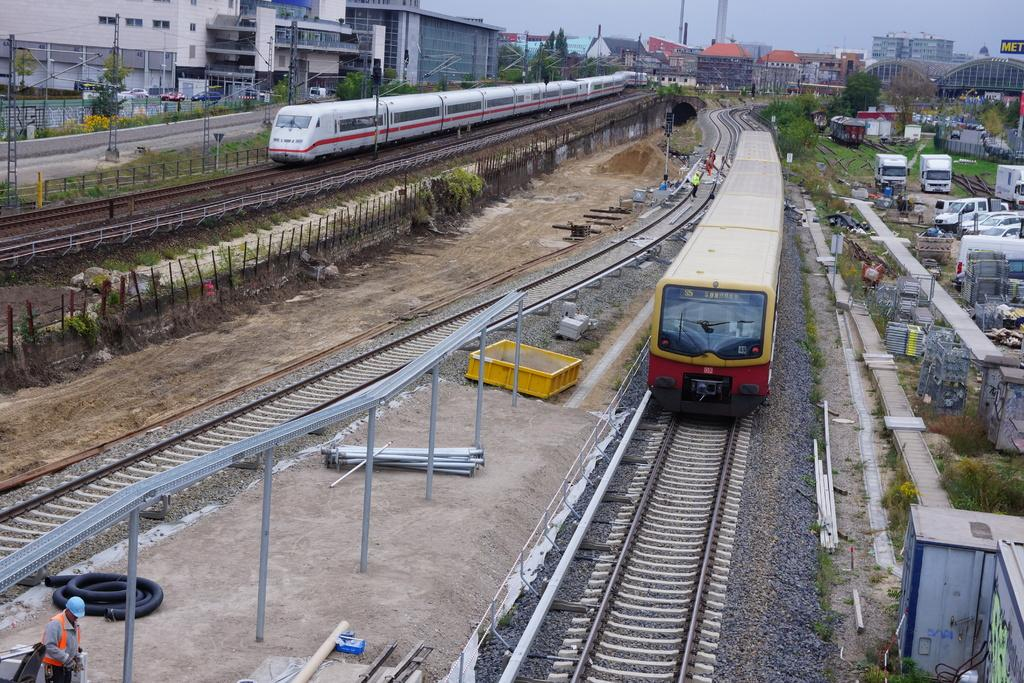How many trains are on the railway track in the image? There are two trains on the railway track in the image. What other objects can be seen in the image besides the trains? Pipes, poles, people, trees, a building, grass, and vehicles are visible in the image. What is the color of the sky in the image? The sky is blue and white in color. How many lizards are crawling on the camera in the image? There is no camera or lizards present in the image. What part of the foot can be seen in the image? There is no foot visible in the image. 